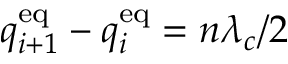Convert formula to latex. <formula><loc_0><loc_0><loc_500><loc_500>q _ { i + 1 } ^ { e q } - q _ { i } ^ { e q } = n \lambda _ { c } / 2</formula> 